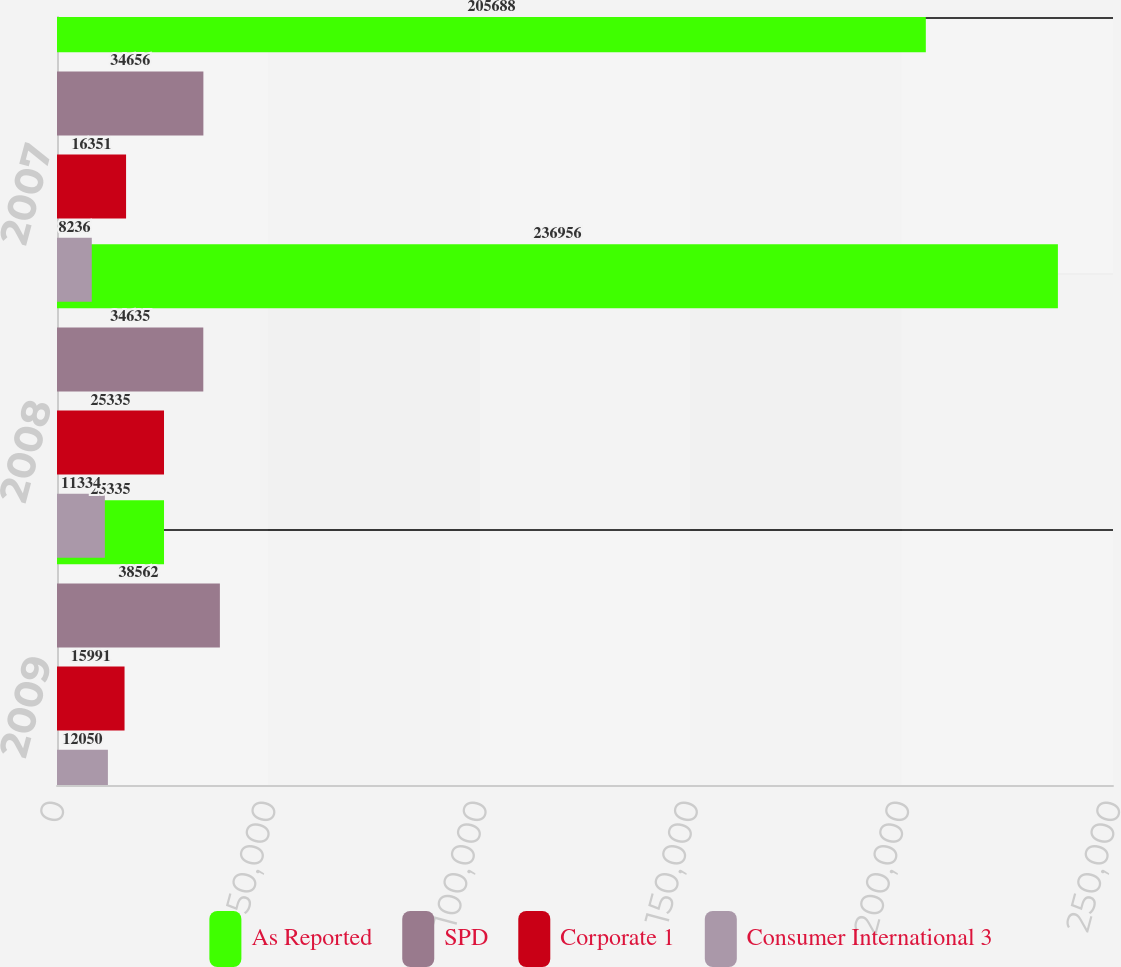<chart> <loc_0><loc_0><loc_500><loc_500><stacked_bar_chart><ecel><fcel>2009<fcel>2008<fcel>2007<nl><fcel>As Reported<fcel>25335<fcel>236956<fcel>205688<nl><fcel>SPD<fcel>38562<fcel>34635<fcel>34656<nl><fcel>Corporate 1<fcel>15991<fcel>25335<fcel>16351<nl><fcel>Consumer International 3<fcel>12050<fcel>11334<fcel>8236<nl></chart> 